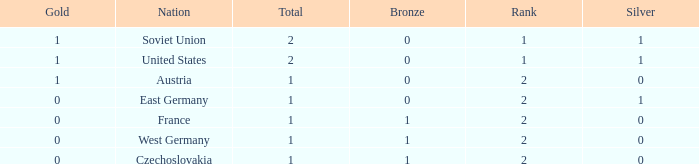What is the rank of the team with 0 gold and less than 0 silvers? None. 